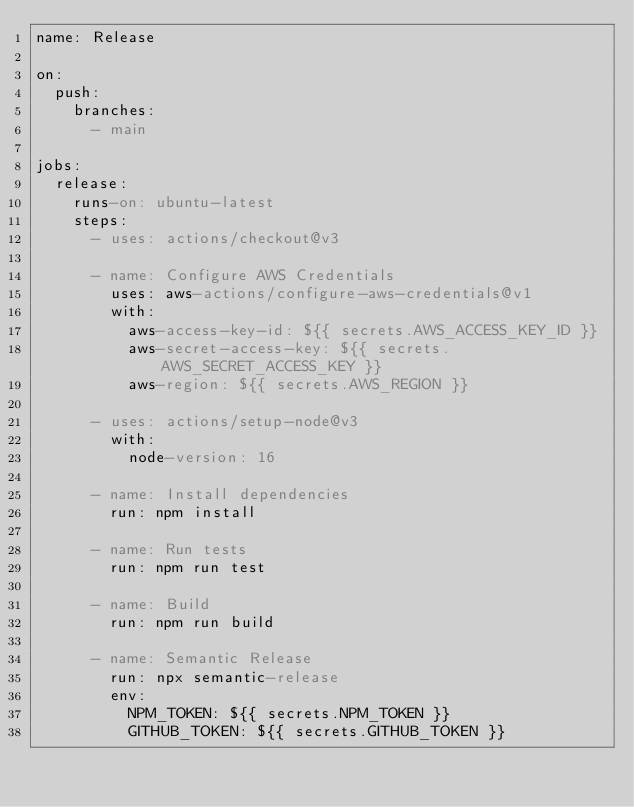<code> <loc_0><loc_0><loc_500><loc_500><_YAML_>name: Release

on:
  push:
    branches:
      - main

jobs:
  release:
    runs-on: ubuntu-latest
    steps:
      - uses: actions/checkout@v3

      - name: Configure AWS Credentials
        uses: aws-actions/configure-aws-credentials@v1
        with:
          aws-access-key-id: ${{ secrets.AWS_ACCESS_KEY_ID }}
          aws-secret-access-key: ${{ secrets.AWS_SECRET_ACCESS_KEY }}
          aws-region: ${{ secrets.AWS_REGION }}

      - uses: actions/setup-node@v3
        with:
          node-version: 16

      - name: Install dependencies
        run: npm install

      - name: Run tests
        run: npm run test

      - name: Build
        run: npm run build

      - name: Semantic Release
        run: npx semantic-release
        env:
          NPM_TOKEN: ${{ secrets.NPM_TOKEN }}
          GITHUB_TOKEN: ${{ secrets.GITHUB_TOKEN }}
</code> 